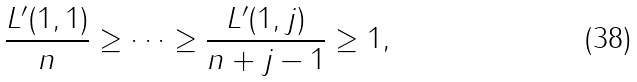<formula> <loc_0><loc_0><loc_500><loc_500>\frac { L ^ { \prime } ( 1 , 1 ) } { n } \geq \dots \geq \frac { L ^ { \prime } ( 1 , j ) } { n + j - 1 } \geq 1 ,</formula> 